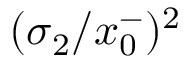Convert formula to latex. <formula><loc_0><loc_0><loc_500><loc_500>( \sigma _ { 2 } / x _ { 0 } ^ { - } ) ^ { 2 }</formula> 